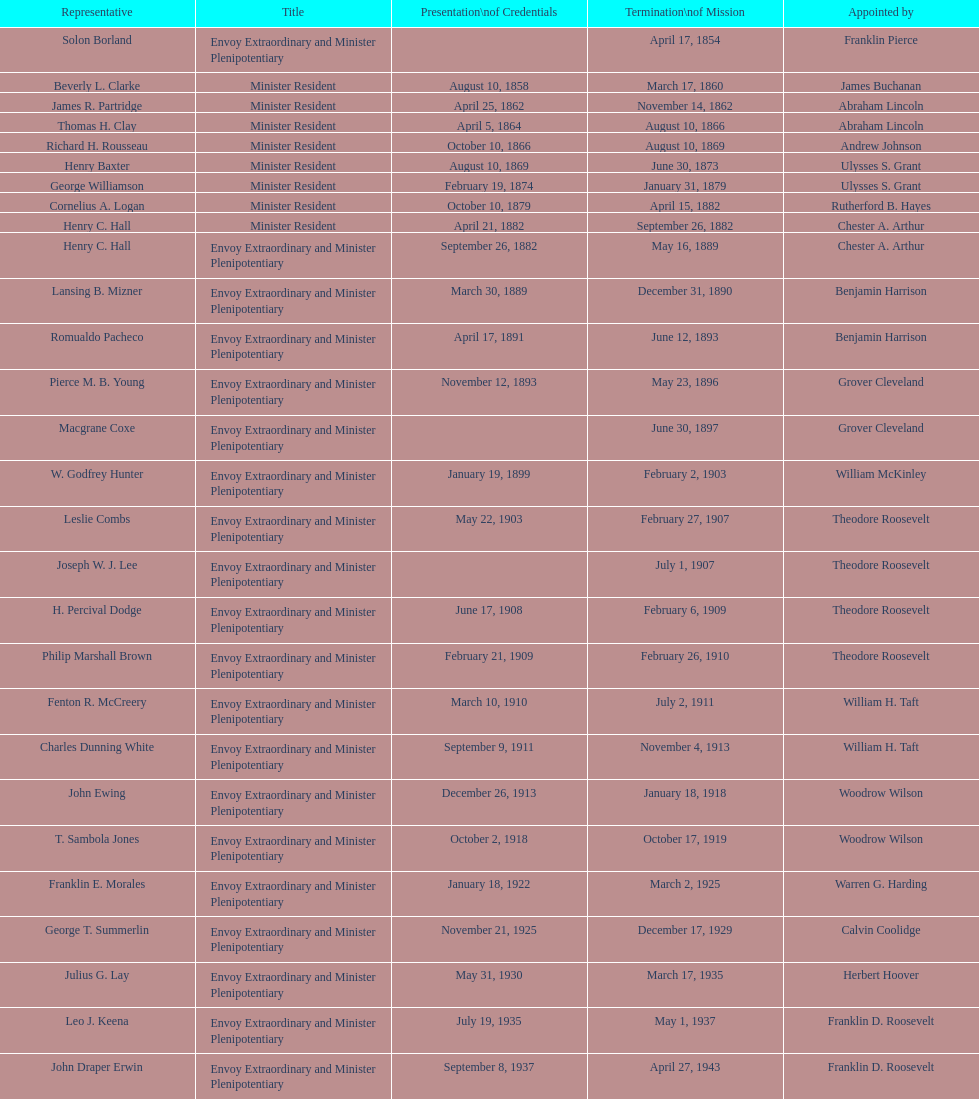Who succeeded hewson ryan as ambassador following the end of his assignment? Phillip V. Sanchez. 